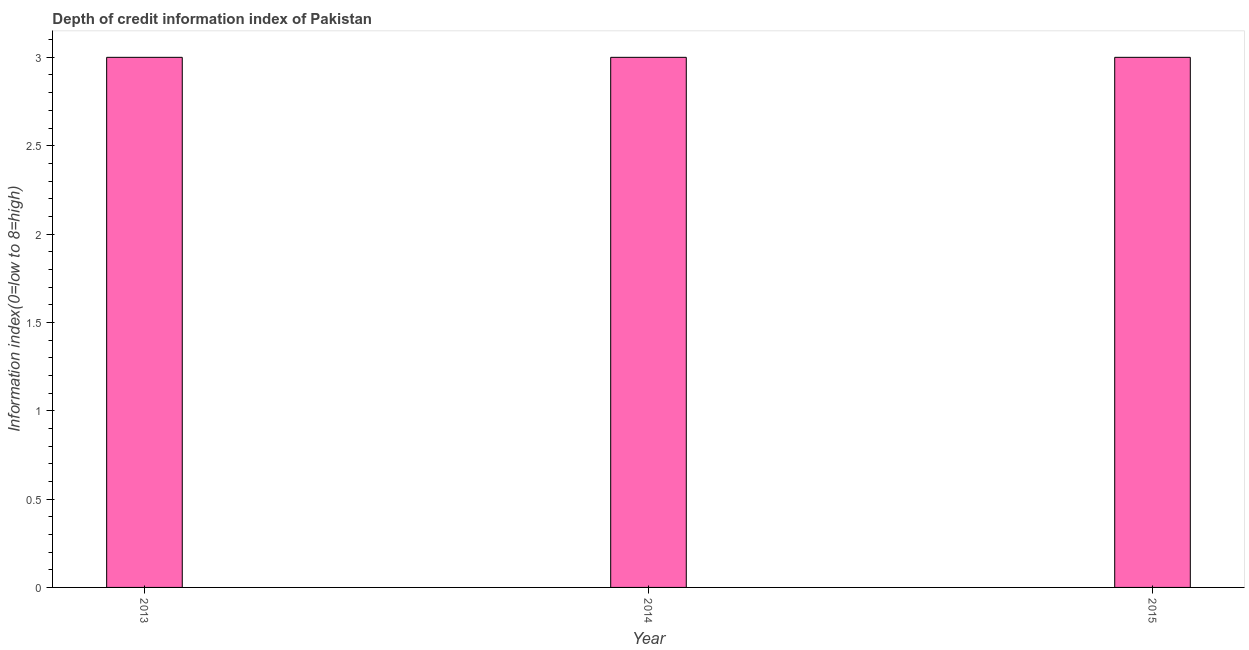Does the graph contain grids?
Give a very brief answer. No. What is the title of the graph?
Provide a succinct answer. Depth of credit information index of Pakistan. What is the label or title of the X-axis?
Your answer should be very brief. Year. What is the label or title of the Y-axis?
Your answer should be compact. Information index(0=low to 8=high). Across all years, what is the maximum depth of credit information index?
Your answer should be very brief. 3. Across all years, what is the minimum depth of credit information index?
Make the answer very short. 3. In which year was the depth of credit information index maximum?
Your response must be concise. 2013. What is the sum of the depth of credit information index?
Provide a succinct answer. 9. What is the average depth of credit information index per year?
Offer a terse response. 3. Do a majority of the years between 2014 and 2013 (inclusive) have depth of credit information index greater than 0.1 ?
Provide a succinct answer. No. What is the difference between the highest and the second highest depth of credit information index?
Provide a succinct answer. 0. Is the sum of the depth of credit information index in 2014 and 2015 greater than the maximum depth of credit information index across all years?
Offer a very short reply. Yes. In how many years, is the depth of credit information index greater than the average depth of credit information index taken over all years?
Your response must be concise. 0. How many bars are there?
Offer a very short reply. 3. Are all the bars in the graph horizontal?
Your answer should be very brief. No. What is the difference between two consecutive major ticks on the Y-axis?
Provide a short and direct response. 0.5. What is the Information index(0=low to 8=high) of 2014?
Offer a very short reply. 3. What is the difference between the Information index(0=low to 8=high) in 2013 and 2014?
Ensure brevity in your answer.  0. What is the ratio of the Information index(0=low to 8=high) in 2014 to that in 2015?
Offer a very short reply. 1. 